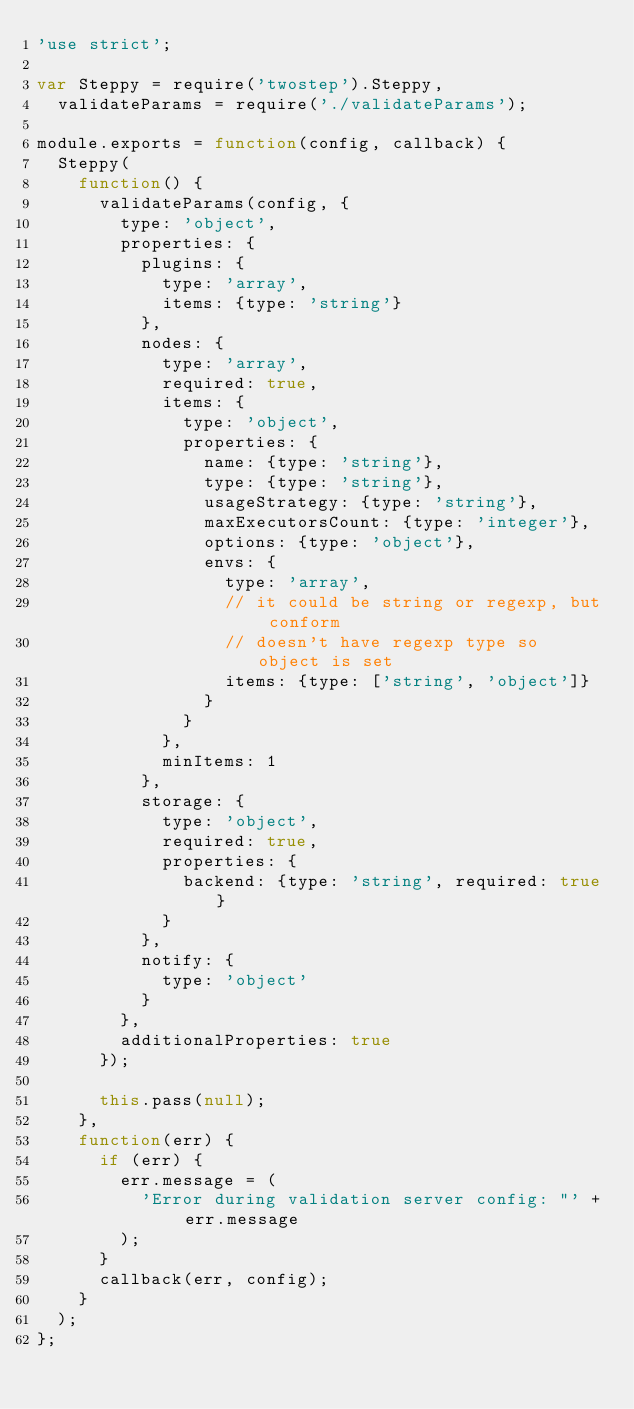Convert code to text. <code><loc_0><loc_0><loc_500><loc_500><_JavaScript_>'use strict';

var Steppy = require('twostep').Steppy,
	validateParams = require('./validateParams');

module.exports = function(config, callback) {
	Steppy(
		function() {
			validateParams(config, {
				type: 'object',
				properties: {
					plugins: {
						type: 'array',
						items: {type: 'string'}
					},
					nodes: {
						type: 'array',
						required: true,
						items: {
							type: 'object',
							properties: {
								name: {type: 'string'},
								type: {type: 'string'},
								usageStrategy: {type: 'string'},
								maxExecutorsCount: {type: 'integer'},
								options: {type: 'object'},
								envs: {
									type: 'array',
									// it could be string or regexp, but conform
									// doesn't have regexp type so object is set
									items: {type: ['string', 'object']}
								}
							}
						},
						minItems: 1
					},
					storage: {
						type: 'object',
						required: true,
						properties: {
							backend: {type: 'string', required: true}
						}
					},
					notify: {
						type: 'object'
					}
				},
				additionalProperties: true
			});

			this.pass(null);
		},
		function(err) {
			if (err) {
				err.message = (
					'Error during validation server config: "' + err.message
				);
			}
			callback(err, config);
		}
	);
};
</code> 